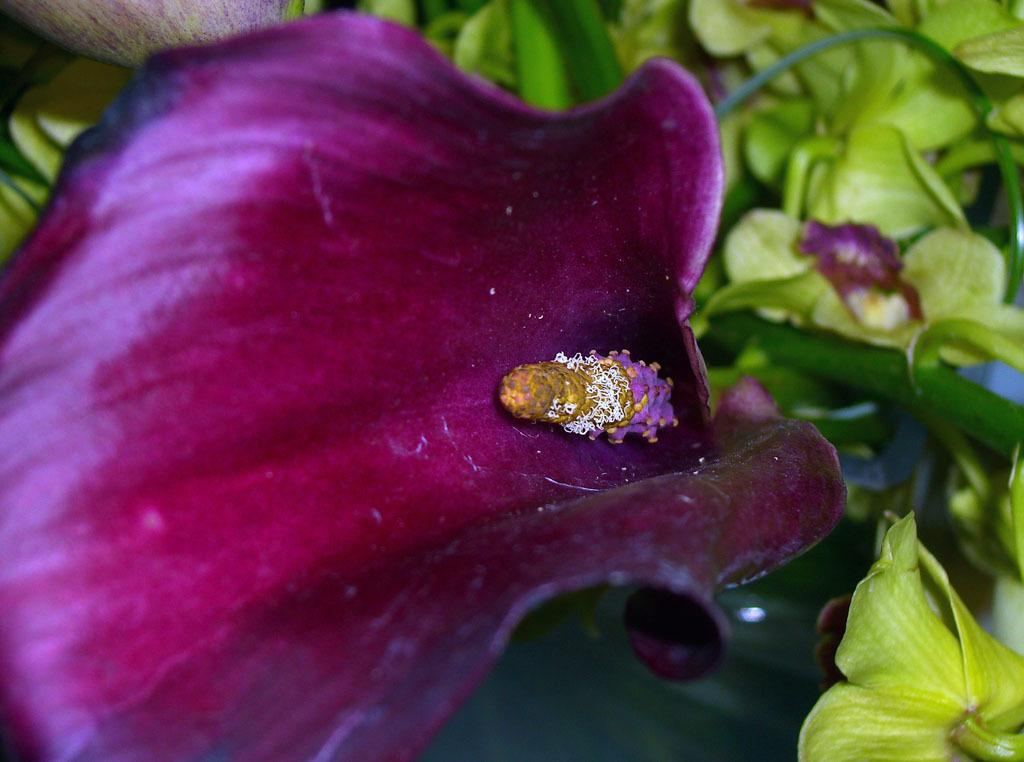What type of plant elements can be seen in the image? There are flowers, leaves, and stems in the image. Can you describe the flowers in the image? Unfortunately, the facts provided do not give specific details about the flowers. What else can be seen in the image besides the flowers? There are leaves and stems in the image. What type of drain is visible in the image? There is no drain present in the image; it features flowers, leaves, and stems. Can you describe the linen used to cover the flowers in the image? There is no linen mentioned or visible in the image; it only features flowers, leaves, and stems. 